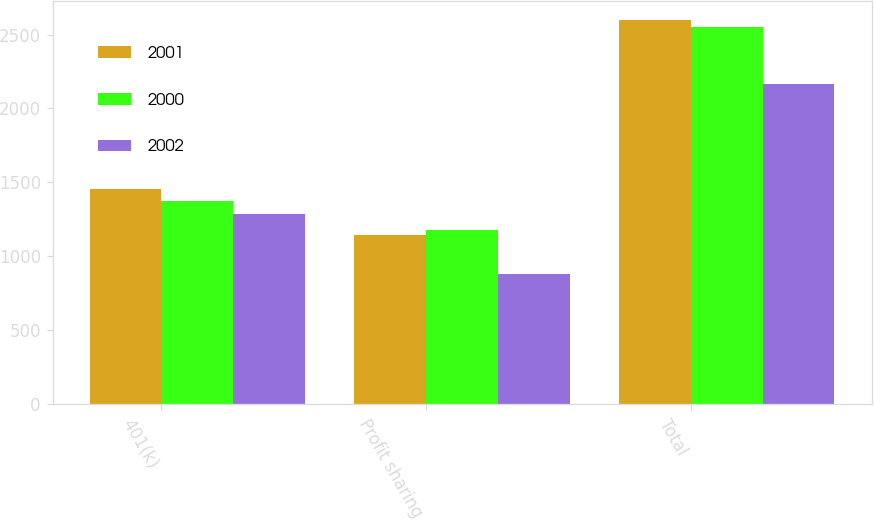Convert chart to OTSL. <chart><loc_0><loc_0><loc_500><loc_500><stacked_bar_chart><ecel><fcel>401(k)<fcel>Profit sharing<fcel>Total<nl><fcel>2001<fcel>1452<fcel>1146<fcel>2598<nl><fcel>2000<fcel>1374<fcel>1178<fcel>2552<nl><fcel>2002<fcel>1287<fcel>877<fcel>2164<nl></chart> 